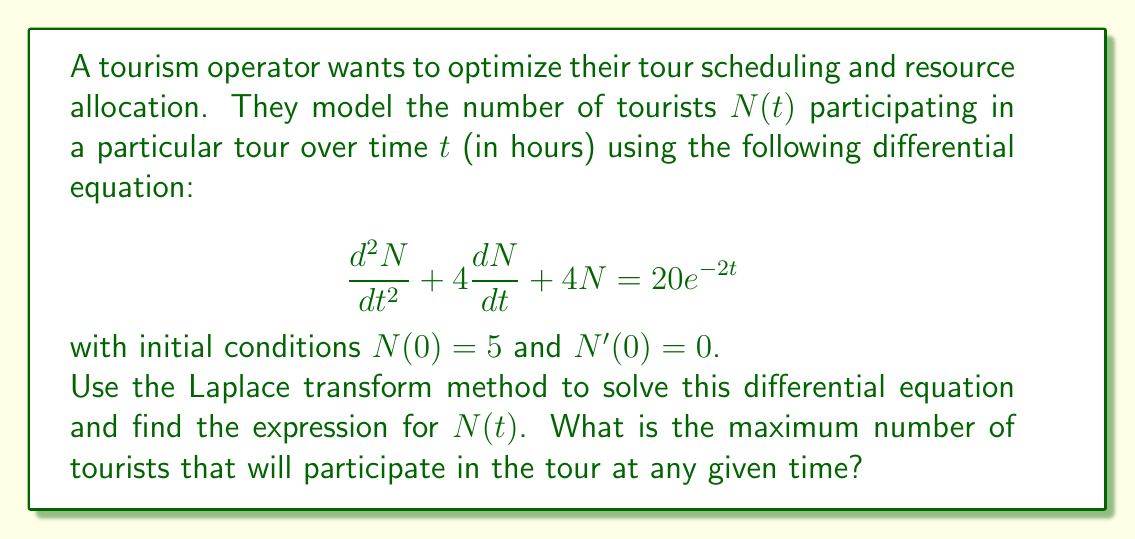Solve this math problem. Let's solve this step-by-step using the Laplace transform method:

1) First, let's take the Laplace transform of both sides of the equation:

   $\mathcal{L}\{N''(t) + 4N'(t) + 4N(t)\} = \mathcal{L}\{20e^{-2t}\}$

2) Using Laplace transform properties:

   $[s^2\mathcal{L}\{N(t)\} - sN(0) - N'(0)] + 4[s\mathcal{L}\{N(t)\} - N(0)] + 4\mathcal{L}\{N(t)\} = \frac{20}{s+2}$

3) Let $\mathcal{L}\{N(t)\} = X(s)$. Substituting the initial conditions:

   $s^2X(s) - 5s + 4sX(s) - 20 + 4X(s) = \frac{20}{s+2}$

4) Simplify:

   $(s^2 + 4s + 4)X(s) = \frac{20}{s+2} + 5s + 20$

5) Solve for $X(s)$:

   $X(s) = \frac{20}{(s+2)(s^2 + 4s + 4)} + \frac{5s + 20}{s^2 + 4s + 4}$

6) Simplify the right side:

   $X(s) = \frac{20}{(s+2)^3} + \frac{5s + 20}{(s+2)^2}$

7) Now, we need to find the inverse Laplace transform. We can use the following inverse Laplace transform formulas:

   $\mathcal{L}^{-1}\{\frac{1}{(s+a)^n}\} = \frac{t^{n-1}e^{-at}}{(n-1)!}$
   
   $\mathcal{L}^{-1}\{\frac{s}{(s+a)^n}\} = \frac{t^{n-2}e^{-at}}{(n-2)!} - \frac{at^{n-1}e^{-at}}{(n-1)!}$

8) Applying these formulas:

   $N(t) = 20\frac{t^2e^{-2t}}{2!} + 5(\frac{e^{-2t}}{0!} - 2\frac{te^{-2t}}{1!}) + 20\frac{te^{-2t}}{1!}$

9) Simplify:

   $N(t) = 10t^2e^{-2t} + 5e^{-2t} - 10te^{-2t} + 20te^{-2t}$
   
   $N(t) = 10t^2e^{-2t} + 10te^{-2t} + 5e^{-2t}$

10) To find the maximum number of tourists, we need to find the maximum value of this function. We can do this by differentiating $N(t)$, setting it to zero, and solving for $t$:

    $N'(t) = 20te^{-2t} - 20t^2e^{-2t} + 10e^{-2t} - 20te^{-2t} + 5e^{-2t} - 10e^{-2t}$
    
    $N'(t) = e^{-2t}(20t - 20t^2 - 5) = 0$

11) Solving this equation:

    $20t - 20t^2 - 5 = 0$
    $20t^2 - 20t + 5 = 0$
    $t^2 - t + \frac{1}{4} = 0$
    
    Using the quadratic formula, we get $t = \frac{1}{2}$

12) The maximum number of tourists occurs at $t = \frac{1}{2}$. Substituting this back into our expression for $N(t)$:

    $N(\frac{1}{2}) = 10(\frac{1}{2})^2e^{-1} + 10(\frac{1}{2})e^{-1} + 5e^{-1} = \frac{15}{2e} \approx 2.76$
Answer: The solution to the differential equation is $N(t) = 10t^2e^{-2t} + 10te^{-2t} + 5e^{-2t}$. The maximum number of tourists participating in the tour at any given time is $\frac{15}{2e} \approx 2.76$ (rounded to two decimal places), occurring at $t = \frac{1}{2}$ hours. 